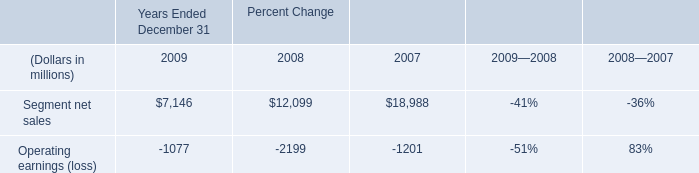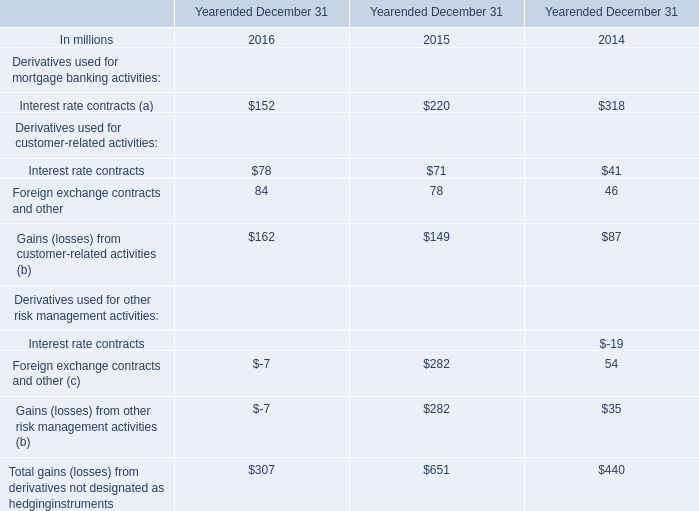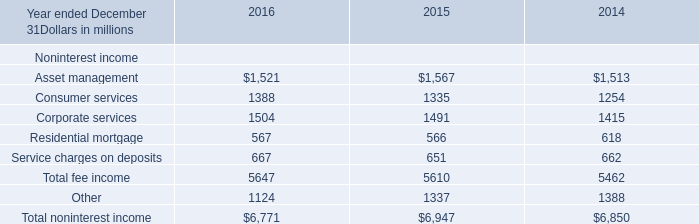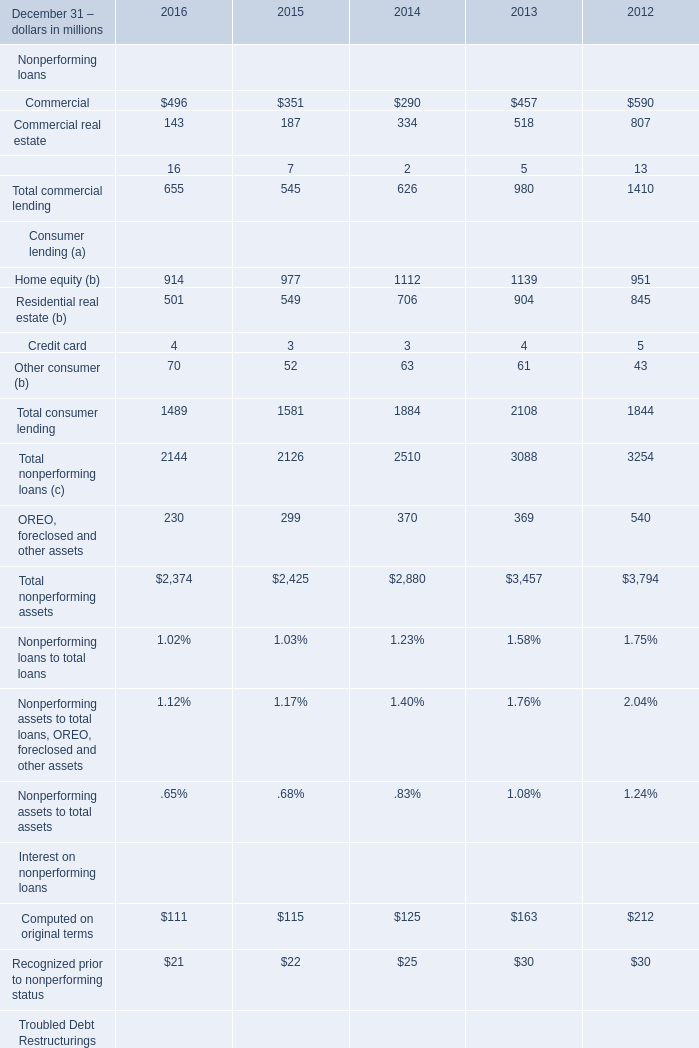What was the total amount of elements in the range of 1300 and 1600 in 2016? (in million) 
Computations: ((1521 + 1388) + 1504)
Answer: 4413.0. 